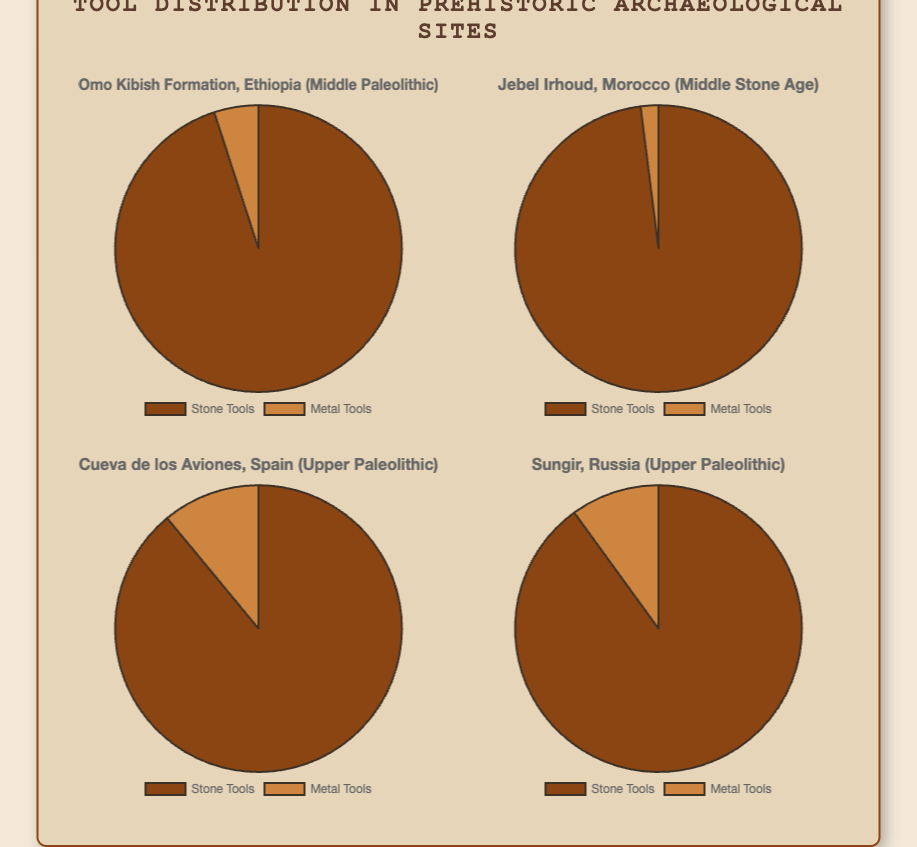What percentage of tools in the Jebel Irhoud site are stone tools? The figure shows a pie chart for the Jebel Irhoud site with segments labeled. The stone tools segment is 98%.
Answer: 98% Which site has the highest percentage of metal tools? By comparing the sizes of the metal tools segments across all pie charts, the Cueva de los Aviones site has the largest metal tools segment at 11%.
Answer: Cueva de los Aviones What is the average percentage of stone tools across all sites? Sum the stone tool percentages for all sites (95 + 98 + 89 + 90) = 372 and divide by the number of sites (4), giving an average of 372 / 4 = 93.
Answer: 93 Which two sites have a 1:9 ratio of metal to stone tools? A ratio of 1:9 means 10% of tools are metal. From the pie charts, Sungir has 10%, so check other sites. Omo Kibish Formation has 5%, Jebel Irhoud has 2%, and Cueva de los Aviones has 11%. Sungir is the only match.
Answer: Sungir Compare the percentages of metal tools between Omo Kibish Formation and Sungir. Which site has more? The pie chart for Omo Kibish Formation shows 5% metal tools, while Sungir shows 10%. Clearly, Sungir has more metal tools.
Answer: Sungir What is the difference in stone tools percentages between Cueva de los Aviones and Jebel Irhoud? Subtract the stone tools percentage of Cueva de los Aviones (89%) from Jebel Irhoud (98%), which equals 98 - 89 = 9.
Answer: 9% Across all sites, are stone or metal tools more prevalent? Sum stone tools percentages (95 + 98 + 89 + 90) = 372 and metal tools percentages (5 + 2 + 11 + 10) = 28. Stone tools have a higher total percentage.
Answer: Stone tools What visual attribute indicates the primary era represented by the sites? The titles of the pie charts include the era for each site. Two sites each are from Middle Paleolithic and Upper Paleolithic eras, denoted in the titles.
Answer: Middle and Upper Paleolithic Which site has the largest difference in percentages between stone and metal tools? Calculate the absolute difference for each site - Omo Kibish Formation (90), Jebel Irhoud (96), Cueva de los Aviones (78), Sungir (80). Jebel Irhoud has the largest difference.
Answer: Jebel Irhoud Compare the ratio of stone to metal tools in Jebel Irhoud to Cueva de los Aviones. Jebel Irhoud has 98% stone to 2% metal, a ratio of 49:1. Cueva de los Aviones has 89% stone to 11% metal, a ratio of 8.09:1. Jebel Irhoud has a higher ratio.
Answer: Jebel Irhoud 